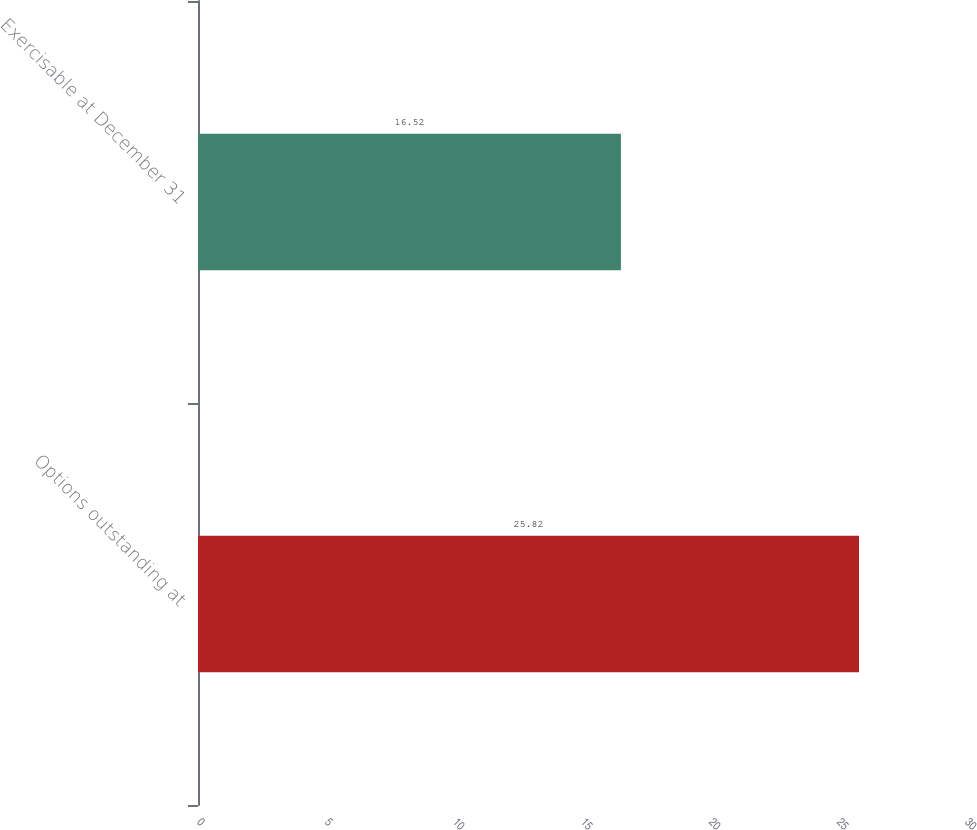Convert chart. <chart><loc_0><loc_0><loc_500><loc_500><bar_chart><fcel>Options outstanding at<fcel>Exercisable at December 31<nl><fcel>25.82<fcel>16.52<nl></chart> 